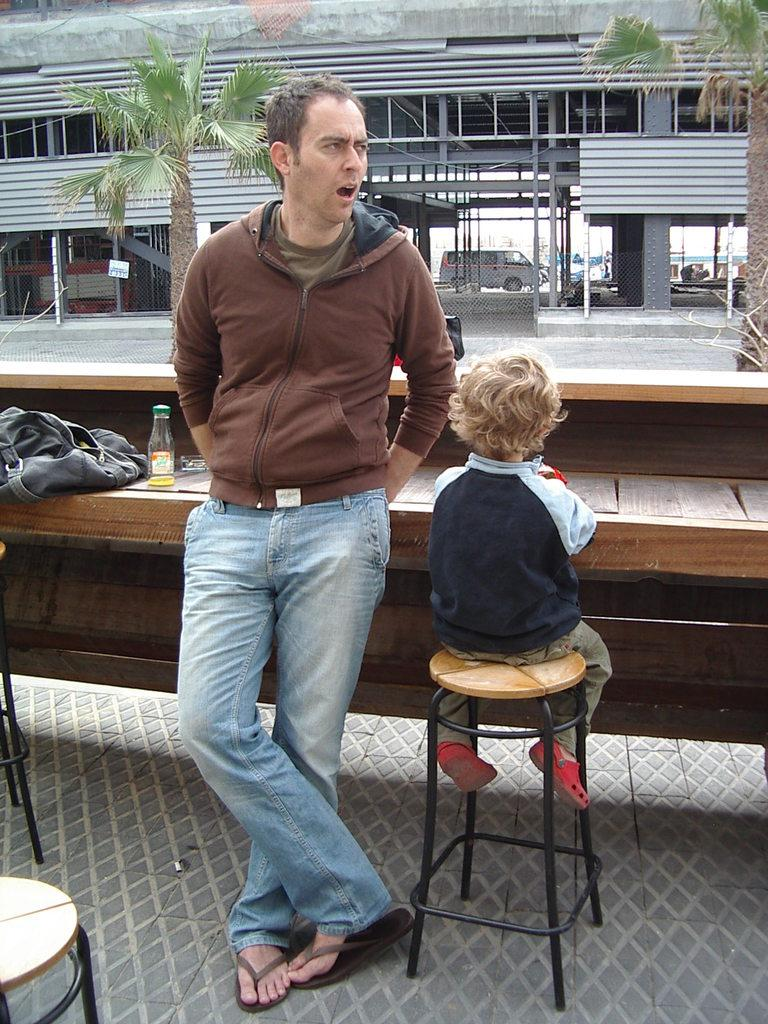What type of setting is shown in the image? The image depicts an open space. What is the kid doing in the image? The kid is sitting on a chair. Who is with the kid in the image? A man is standing beside the kid. What is between the kid and the man? There is a table in front of the kid and the man. What can be seen behind the table? There is a building behind the table. What is visible behind the building? Two trees are visible behind the building. What else is present in the scene? A vehicle is present in the scene. What is the man doing to express his anger in the image? There is no indication of anger or any specific action being performed by the man in the image. 